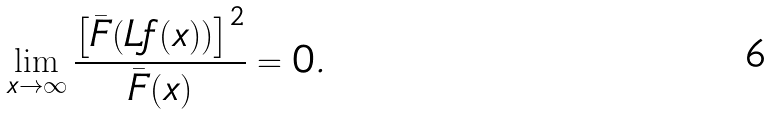<formula> <loc_0><loc_0><loc_500><loc_500>\lim _ { x \to \infty } \frac { { \left [ \bar { F } ( L f ( x ) ) \right ] } ^ { 2 } } { \bar { F } ( x ) } = 0 .</formula> 